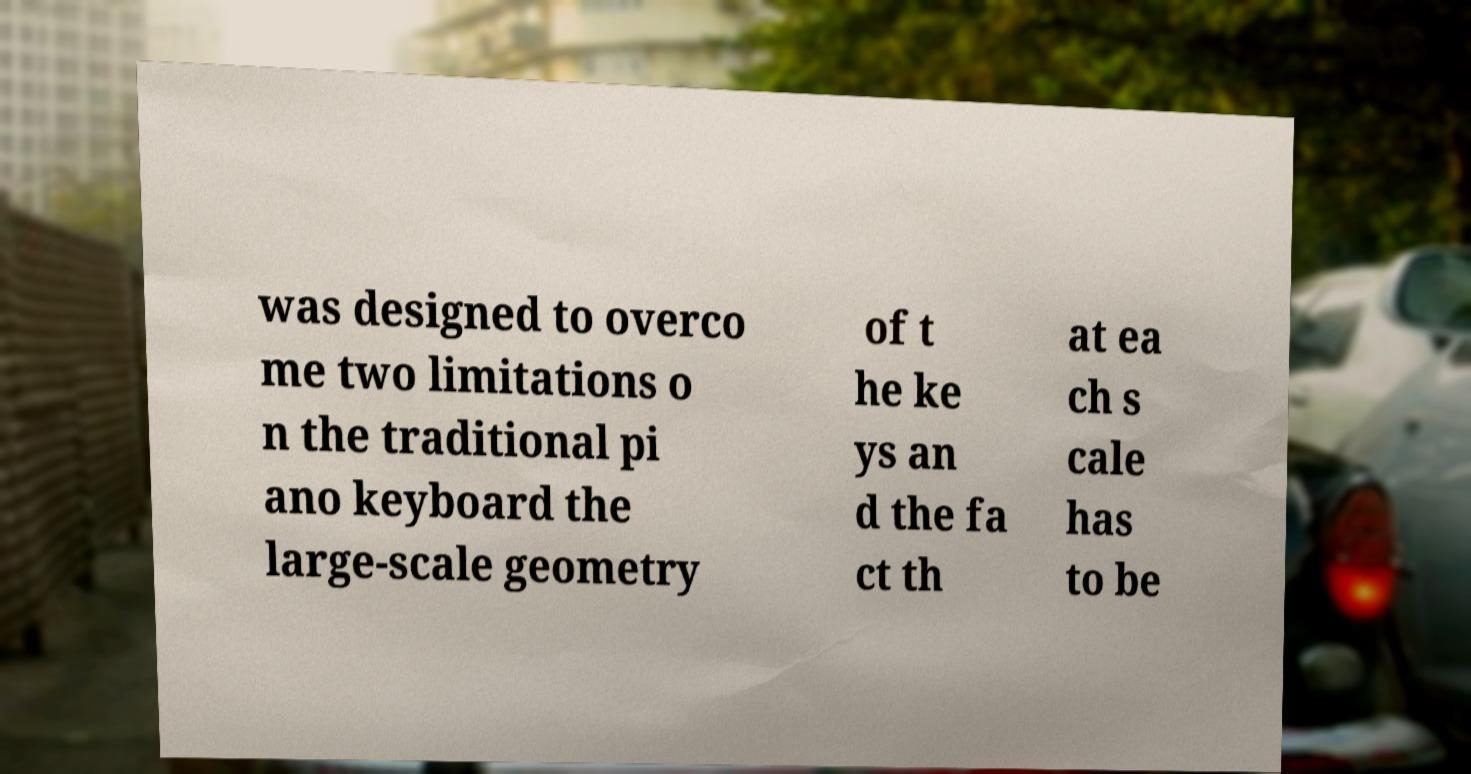For documentation purposes, I need the text within this image transcribed. Could you provide that? was designed to overco me two limitations o n the traditional pi ano keyboard the large-scale geometry of t he ke ys an d the fa ct th at ea ch s cale has to be 